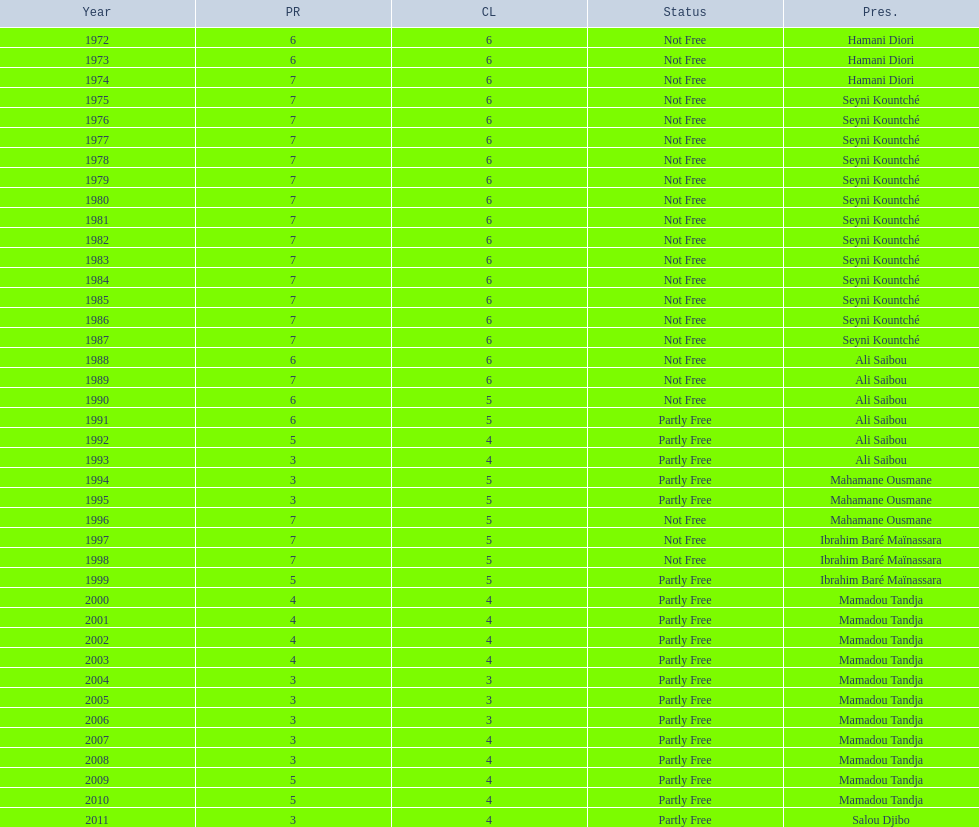How many years was it before the first partly free status? 18. 